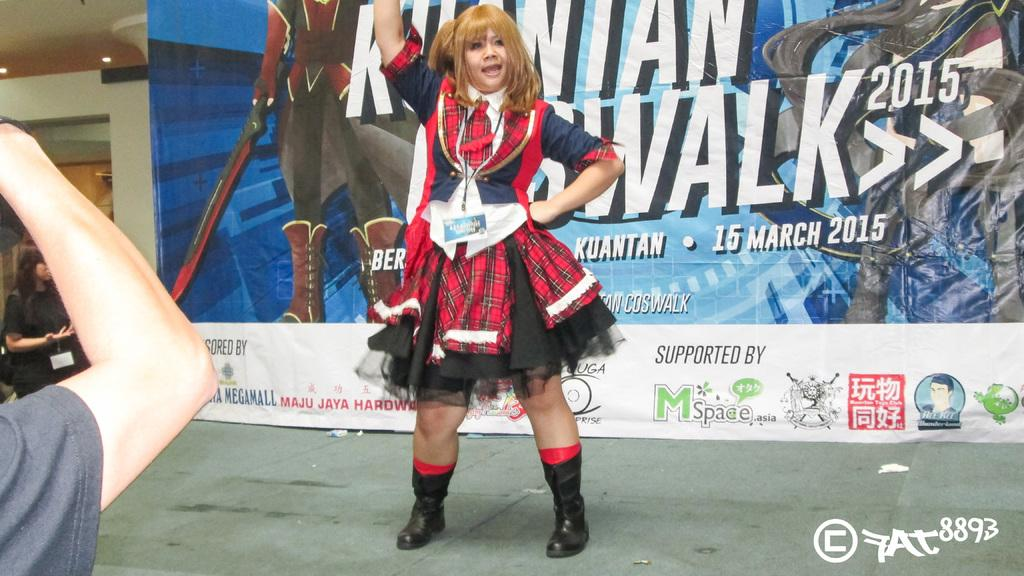<image>
Provide a brief description of the given image. A woman poses for photos in front of a sign that indicates this event was happening in 2015. 